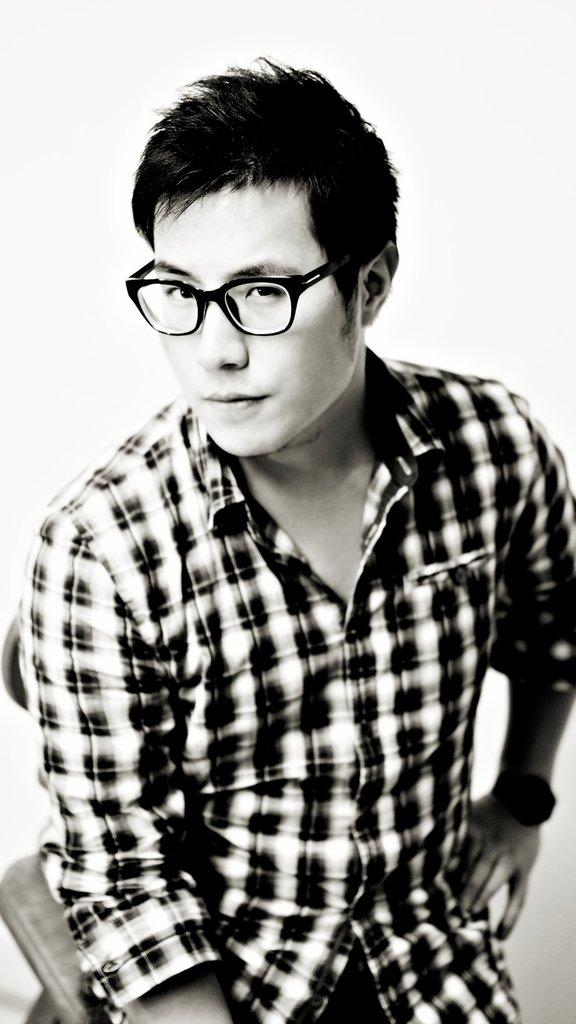What is the color scheme of the image? The image is black and white. Can you describe the person in the image? The person in the image is wearing spectacles. What can be seen behind the person? There is a background in the image. What else is present in the image besides the person? There is an object in the image. How does the person adjust the fire in the image? There is no fire present in the image, so the person cannot adjust it. 